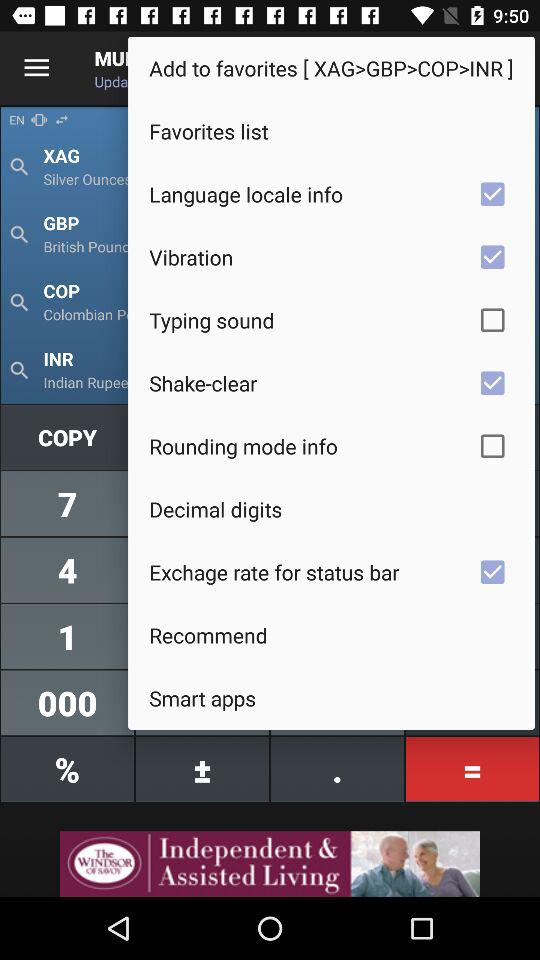What is the status of "Shake-clear"? The status of "Shake-clear" is "on". 